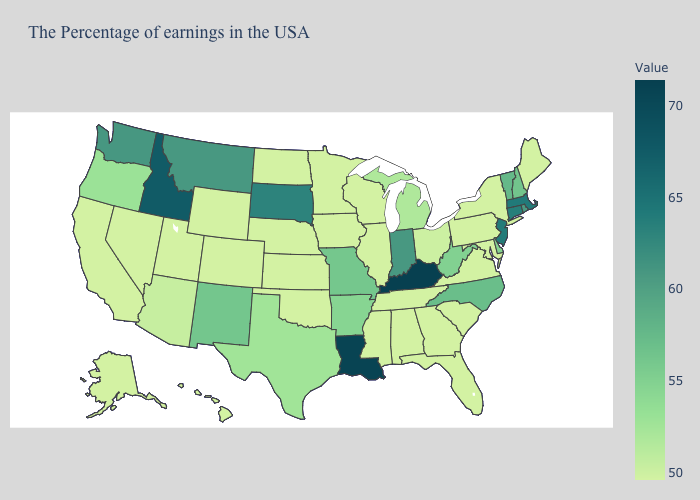Does Indiana have a higher value than South Dakota?
Give a very brief answer. No. Among the states that border Montana , which have the highest value?
Answer briefly. Idaho. Among the states that border Arkansas , which have the lowest value?
Give a very brief answer. Tennessee, Mississippi, Oklahoma. 